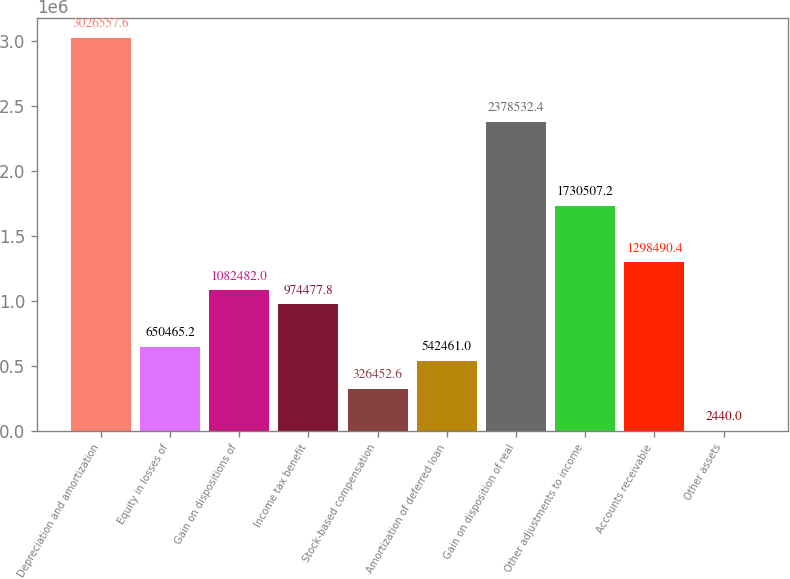<chart> <loc_0><loc_0><loc_500><loc_500><bar_chart><fcel>Depreciation and amortization<fcel>Equity in losses of<fcel>Gain on dispositions of<fcel>Income tax benefit<fcel>Stock-based compensation<fcel>Amortization of deferred loan<fcel>Gain on disposition of real<fcel>Other adjustments to income<fcel>Accounts receivable<fcel>Other assets<nl><fcel>3.02656e+06<fcel>650465<fcel>1.08248e+06<fcel>974478<fcel>326453<fcel>542461<fcel>2.37853e+06<fcel>1.73051e+06<fcel>1.29849e+06<fcel>2440<nl></chart> 